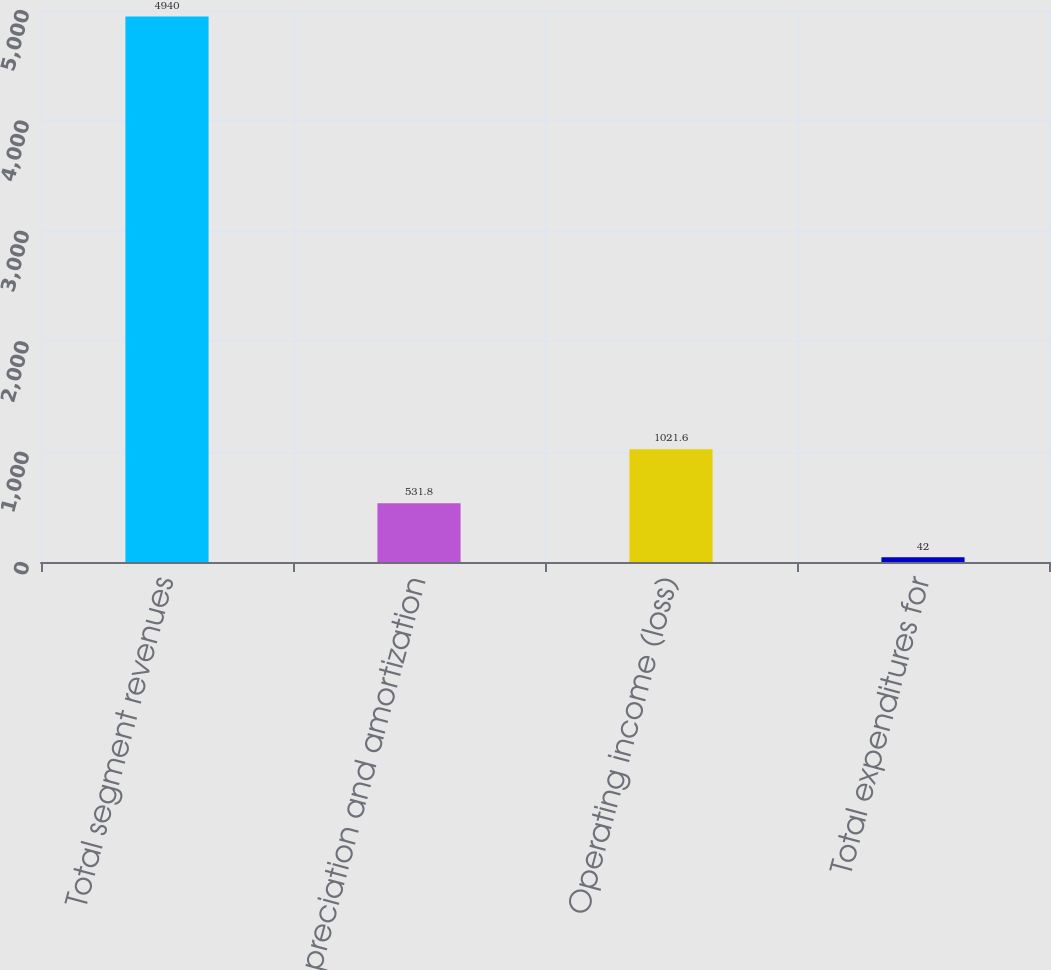<chart> <loc_0><loc_0><loc_500><loc_500><bar_chart><fcel>Total segment revenues<fcel>Depreciation and amortization<fcel>Operating income (loss)<fcel>Total expenditures for<nl><fcel>4940<fcel>531.8<fcel>1021.6<fcel>42<nl></chart> 